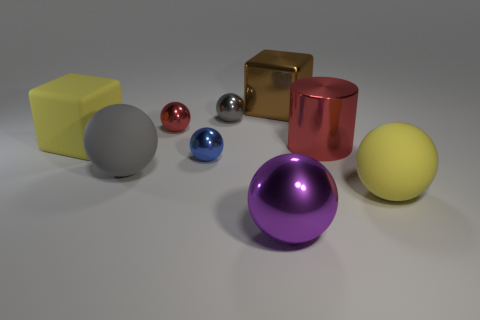Subtract all blue metallic balls. How many balls are left? 5 Subtract all yellow spheres. How many spheres are left? 5 Subtract 2 balls. How many balls are left? 4 Subtract all red cubes. How many red spheres are left? 1 Add 1 green shiny cubes. How many objects exist? 10 Subtract all cylinders. How many objects are left? 8 Subtract all cyan cubes. Subtract all brown spheres. How many cubes are left? 2 Add 6 big gray rubber objects. How many big gray rubber objects are left? 7 Add 5 large metal cylinders. How many large metal cylinders exist? 6 Subtract 1 blue spheres. How many objects are left? 8 